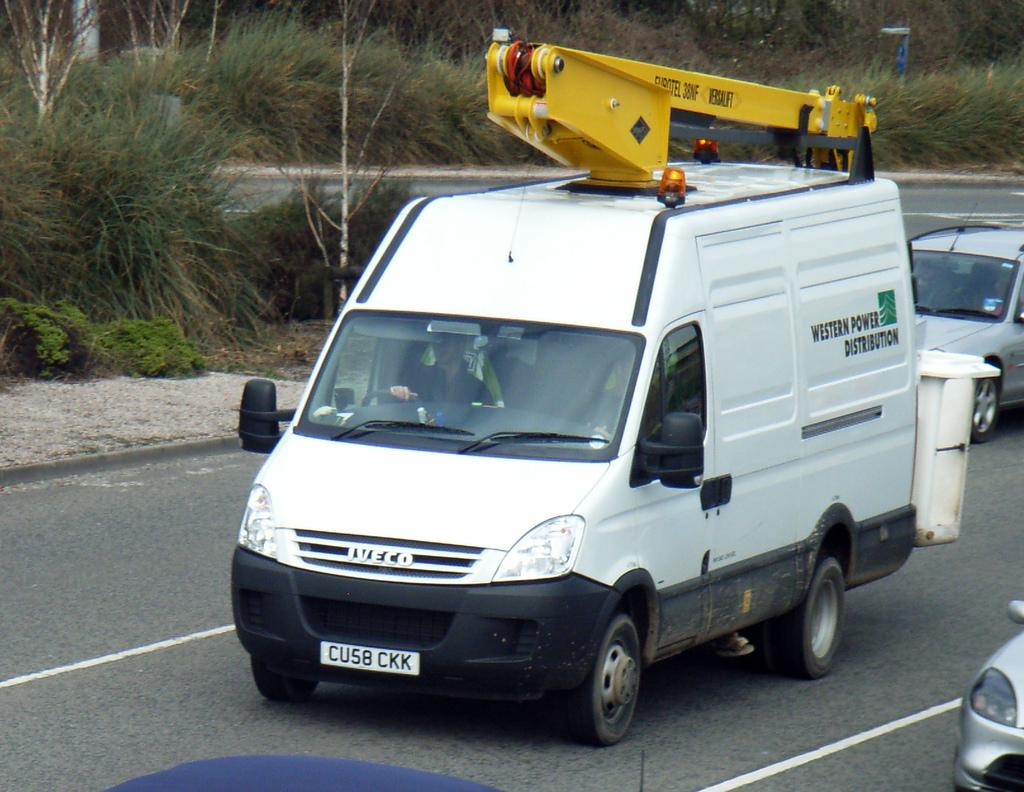<image>
Provide a brief description of the given image. a WESTERN POWER DISTRIBUTION company van with a CU58 CKK license plate. 